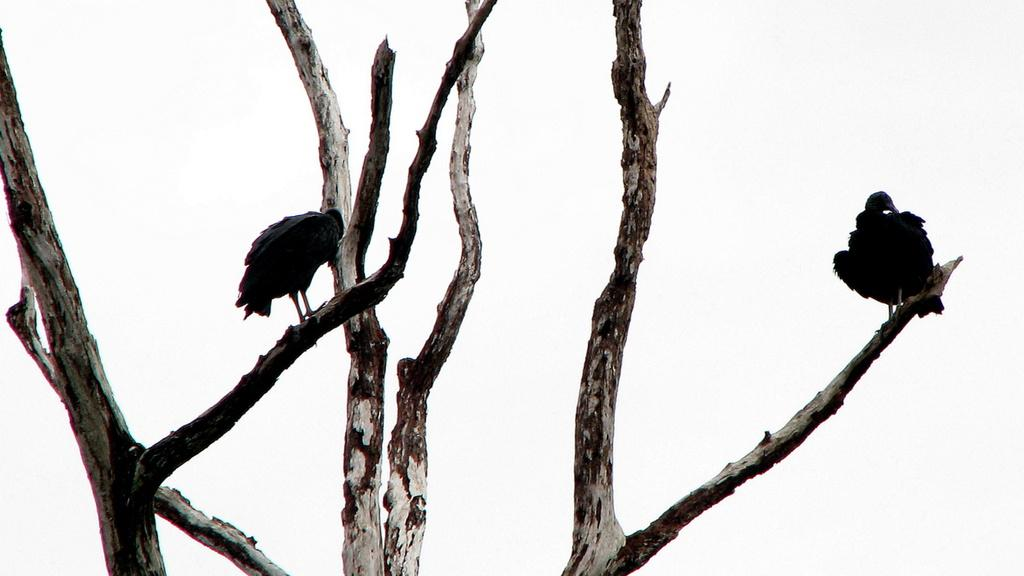What type of animals are in the image? There are two black colored birds in the image. Where are the birds located? The birds are on branches. What is the color of the background in the image? The background of the image is white. How many babies are present in the image? There are no babies present in the image; it features two black colored birds on branches with a white background. What type of current is flowing through the branches in the image? There is no current visible in the image; it only shows two black colored birds on branches with a white background. 